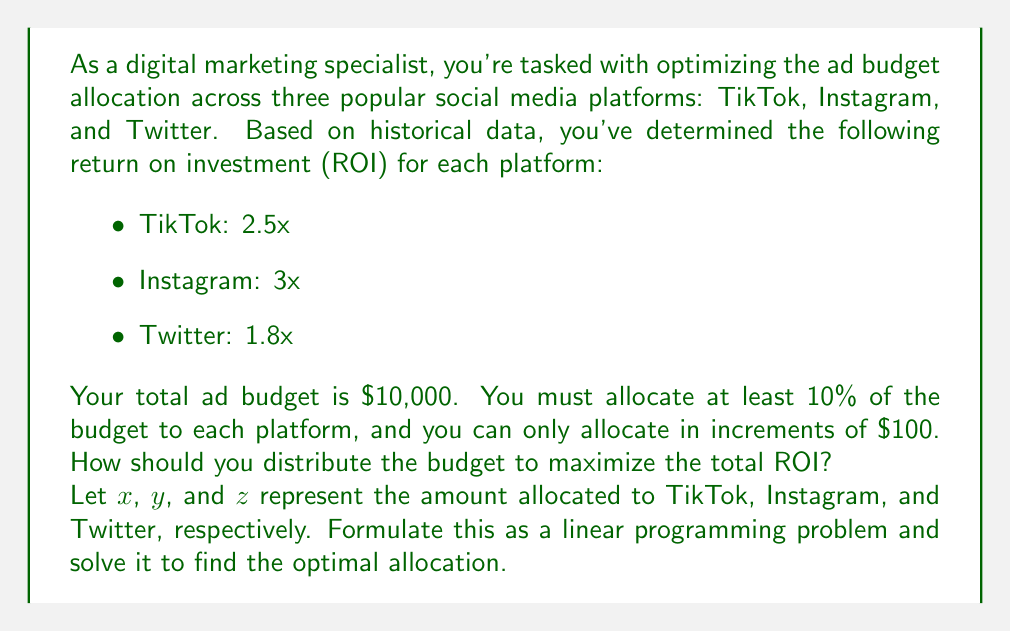Can you solve this math problem? To solve this optimization problem, we'll follow these steps:

1. Formulate the linear programming problem:

Objective function: Maximize $2.5x + 3y + 1.8z$

Constraints:
$$x + y + z = 10000$$ (total budget)
$$x \geq 1000, y \geq 1000, z \geq 1000$$ (minimum 10% allocation)
$$x, y, z \text{ are multiples of 100}$$ (increment constraint)

2. Observe that the highest ROI is for Instagram (3x), followed by TikTok (2.5x), and then Twitter (1.8x).

3. To maximize the total ROI, we should allocate as much as possible to Instagram, then TikTok, and finally Twitter, while respecting the constraints.

4. Allocate the minimum 10% ($1000) to Twitter:
   $z = 1000$

5. Of the remaining $9000, allocate as much as possible to Instagram while respecting the 10% minimum for TikTok:
   $y = 8000$
   $x = 1000$

6. Verify that this allocation satisfies all constraints:
   - Total budget: $1000 + 8000 + 1000 = 10000$
   - Minimum 10% allocation: Met for all platforms
   - Increment of $100: Met for all platforms

7. Calculate the total ROI:
   $2.5(1000) + 3(8000) + 1.8(1000) = 2500 + 24000 + 1800 = 28300$

This allocation maximizes the total ROI while satisfying all constraints.
Answer: The optimal budget allocation is:
TikTok: $1000
Instagram: $8000
Twitter: $1000

The maximum total ROI achieved is $28300. 